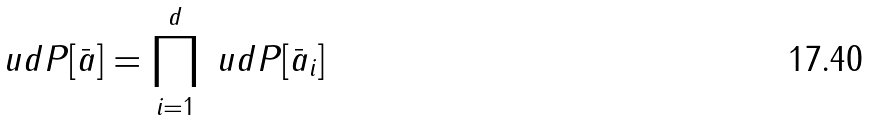<formula> <loc_0><loc_0><loc_500><loc_500>\ u d P [ \bar { a } ] = \prod _ { i = 1 } ^ { d } \ u d P [ \bar { a } _ { i } ]</formula> 